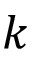<formula> <loc_0><loc_0><loc_500><loc_500>k</formula> 